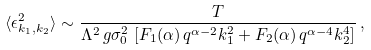<formula> <loc_0><loc_0><loc_500><loc_500>\langle \epsilon _ { k _ { 1 } , k _ { 2 } } ^ { 2 } \rangle \sim \frac { T } { \Lambda ^ { 2 } \, g \sigma _ { 0 } ^ { 2 } \, \left [ F _ { 1 } ( \alpha ) \, q ^ { \alpha - 2 } k _ { 1 } ^ { 2 } + F _ { 2 } ( \alpha ) \, q ^ { \alpha - 4 } k _ { 2 } ^ { 4 } \right ] } \, ,</formula> 